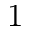<formula> <loc_0><loc_0><loc_500><loc_500>1</formula> 